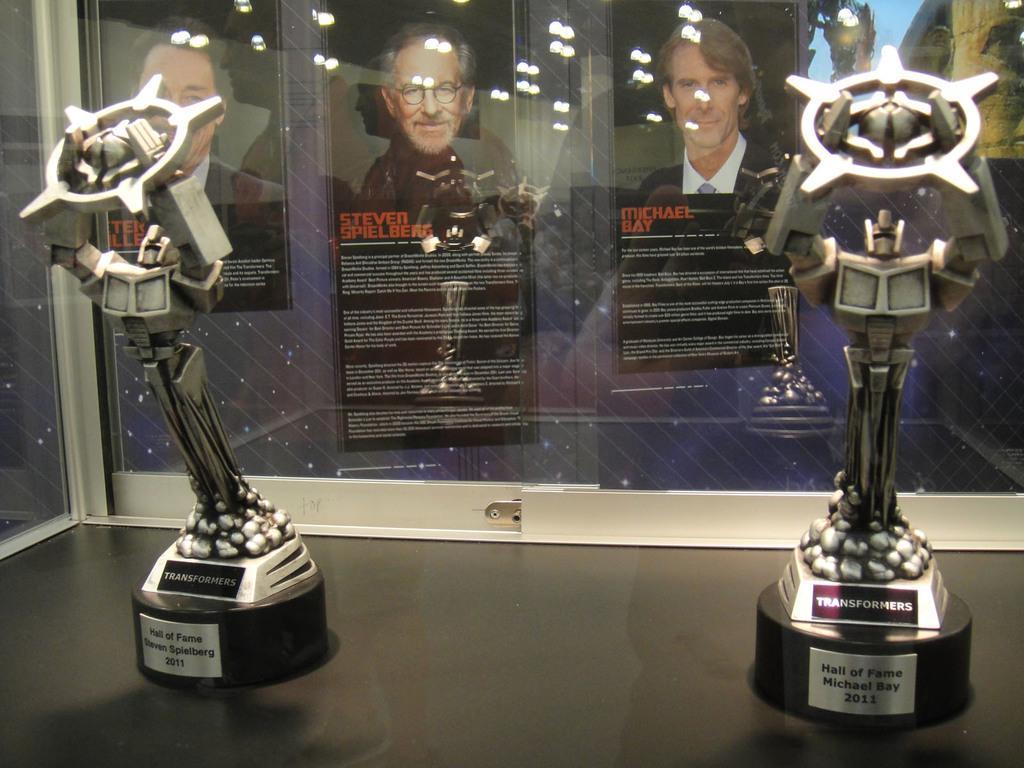In one or two sentences, can you explain what this image depicts? In this image there are two transformers trophies in a glass box, and in the background there are frames attached to the wall , and there are reflections of group of people and lights. 